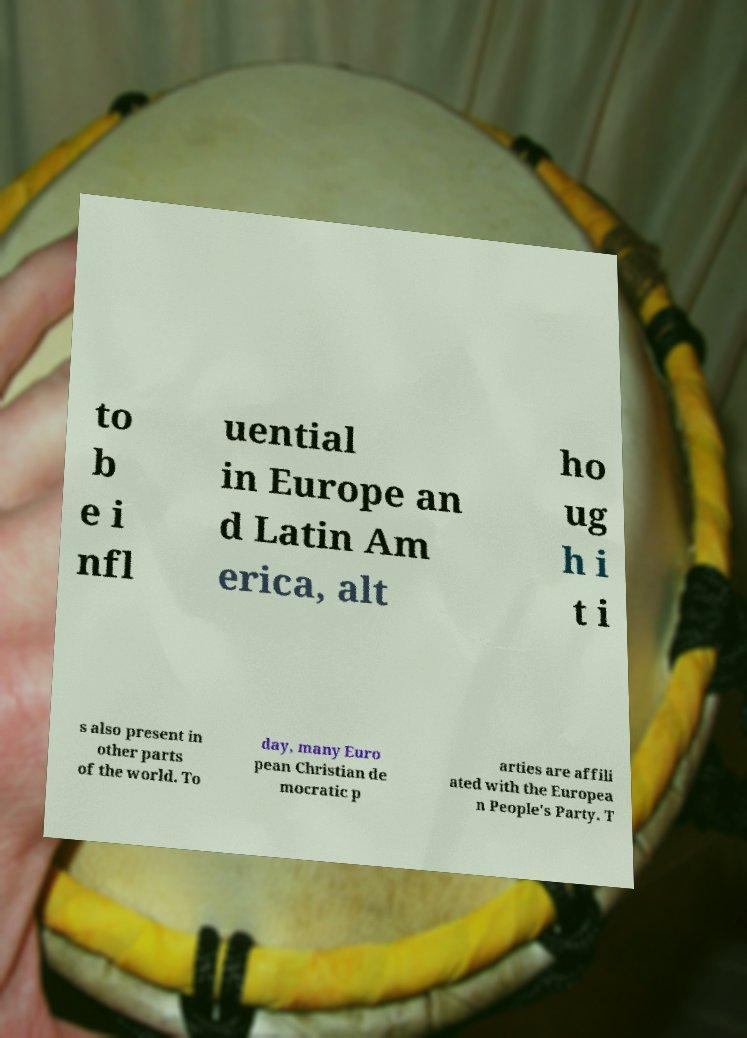I need the written content from this picture converted into text. Can you do that? to b e i nfl uential in Europe an d Latin Am erica, alt ho ug h i t i s also present in other parts of the world. To day, many Euro pean Christian de mocratic p arties are affili ated with the Europea n People's Party. T 